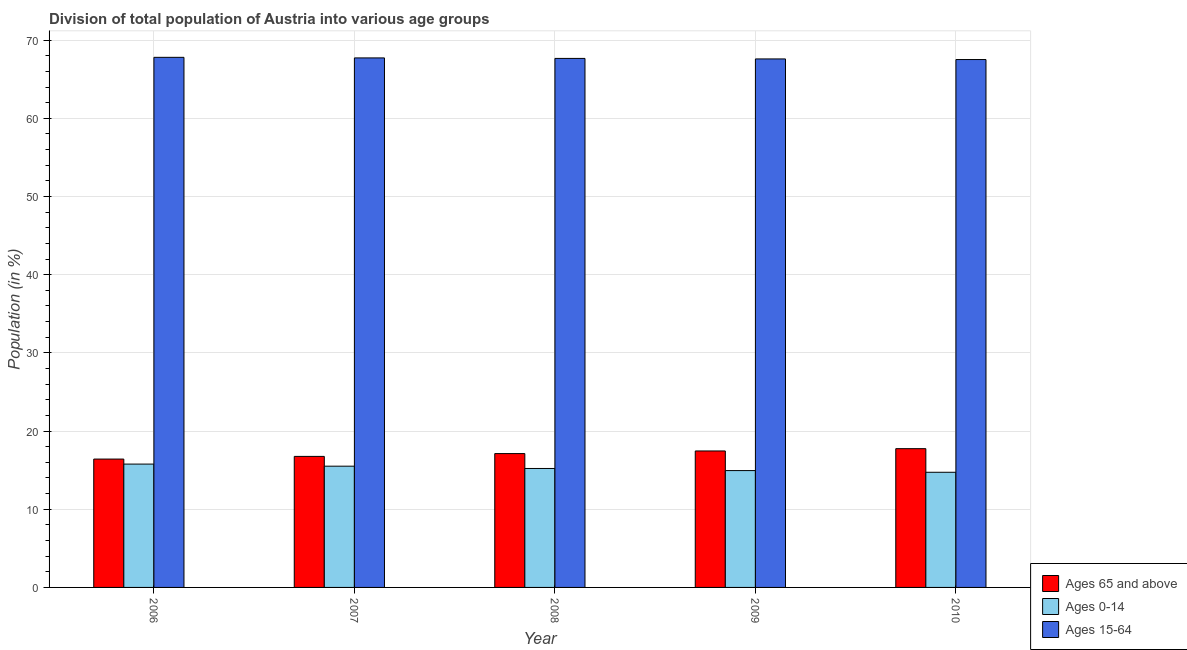How many groups of bars are there?
Your answer should be very brief. 5. Are the number of bars per tick equal to the number of legend labels?
Keep it short and to the point. Yes. How many bars are there on the 1st tick from the left?
Your response must be concise. 3. How many bars are there on the 1st tick from the right?
Your answer should be very brief. 3. What is the label of the 3rd group of bars from the left?
Ensure brevity in your answer.  2008. In how many cases, is the number of bars for a given year not equal to the number of legend labels?
Offer a terse response. 0. What is the percentage of population within the age-group 15-64 in 2006?
Ensure brevity in your answer.  67.81. Across all years, what is the maximum percentage of population within the age-group 15-64?
Your answer should be very brief. 67.81. Across all years, what is the minimum percentage of population within the age-group 0-14?
Ensure brevity in your answer.  14.73. In which year was the percentage of population within the age-group of 65 and above maximum?
Offer a terse response. 2010. What is the total percentage of population within the age-group 15-64 in the graph?
Your answer should be compact. 338.33. What is the difference between the percentage of population within the age-group 15-64 in 2007 and that in 2010?
Provide a succinct answer. 0.21. What is the difference between the percentage of population within the age-group 15-64 in 2006 and the percentage of population within the age-group of 65 and above in 2009?
Ensure brevity in your answer.  0.21. What is the average percentage of population within the age-group 0-14 per year?
Make the answer very short. 15.23. In the year 2008, what is the difference between the percentage of population within the age-group 15-64 and percentage of population within the age-group 0-14?
Provide a succinct answer. 0. What is the ratio of the percentage of population within the age-group of 65 and above in 2006 to that in 2010?
Your response must be concise. 0.93. Is the difference between the percentage of population within the age-group of 65 and above in 2007 and 2008 greater than the difference between the percentage of population within the age-group 15-64 in 2007 and 2008?
Make the answer very short. No. What is the difference between the highest and the second highest percentage of population within the age-group 0-14?
Your response must be concise. 0.27. What is the difference between the highest and the lowest percentage of population within the age-group 0-14?
Offer a terse response. 1.05. In how many years, is the percentage of population within the age-group 15-64 greater than the average percentage of population within the age-group 15-64 taken over all years?
Make the answer very short. 3. Is the sum of the percentage of population within the age-group of 65 and above in 2008 and 2009 greater than the maximum percentage of population within the age-group 15-64 across all years?
Give a very brief answer. Yes. What does the 2nd bar from the left in 2009 represents?
Provide a short and direct response. Ages 0-14. What does the 2nd bar from the right in 2010 represents?
Your answer should be compact. Ages 0-14. How many bars are there?
Offer a very short reply. 15. How many years are there in the graph?
Your answer should be very brief. 5. What is the difference between two consecutive major ticks on the Y-axis?
Offer a very short reply. 10. Where does the legend appear in the graph?
Make the answer very short. Bottom right. How are the legend labels stacked?
Your response must be concise. Vertical. What is the title of the graph?
Your answer should be compact. Division of total population of Austria into various age groups
. What is the label or title of the X-axis?
Give a very brief answer. Year. What is the Population (in %) in Ages 65 and above in 2006?
Your answer should be compact. 16.42. What is the Population (in %) in Ages 0-14 in 2006?
Provide a short and direct response. 15.78. What is the Population (in %) of Ages 15-64 in 2006?
Give a very brief answer. 67.81. What is the Population (in %) of Ages 65 and above in 2007?
Ensure brevity in your answer.  16.76. What is the Population (in %) in Ages 0-14 in 2007?
Give a very brief answer. 15.51. What is the Population (in %) in Ages 15-64 in 2007?
Your answer should be very brief. 67.73. What is the Population (in %) of Ages 65 and above in 2008?
Keep it short and to the point. 17.12. What is the Population (in %) of Ages 0-14 in 2008?
Keep it short and to the point. 15.21. What is the Population (in %) in Ages 15-64 in 2008?
Keep it short and to the point. 67.67. What is the Population (in %) in Ages 65 and above in 2009?
Provide a succinct answer. 17.46. What is the Population (in %) in Ages 0-14 in 2009?
Give a very brief answer. 14.95. What is the Population (in %) in Ages 15-64 in 2009?
Provide a short and direct response. 67.6. What is the Population (in %) of Ages 65 and above in 2010?
Offer a terse response. 17.75. What is the Population (in %) of Ages 0-14 in 2010?
Make the answer very short. 14.73. What is the Population (in %) in Ages 15-64 in 2010?
Ensure brevity in your answer.  67.52. Across all years, what is the maximum Population (in %) of Ages 65 and above?
Provide a short and direct response. 17.75. Across all years, what is the maximum Population (in %) in Ages 0-14?
Give a very brief answer. 15.78. Across all years, what is the maximum Population (in %) of Ages 15-64?
Give a very brief answer. 67.81. Across all years, what is the minimum Population (in %) in Ages 65 and above?
Give a very brief answer. 16.42. Across all years, what is the minimum Population (in %) of Ages 0-14?
Keep it short and to the point. 14.73. Across all years, what is the minimum Population (in %) in Ages 15-64?
Keep it short and to the point. 67.52. What is the total Population (in %) of Ages 65 and above in the graph?
Offer a terse response. 85.5. What is the total Population (in %) of Ages 0-14 in the graph?
Your response must be concise. 76.17. What is the total Population (in %) of Ages 15-64 in the graph?
Ensure brevity in your answer.  338.33. What is the difference between the Population (in %) in Ages 65 and above in 2006 and that in 2007?
Make the answer very short. -0.34. What is the difference between the Population (in %) in Ages 0-14 in 2006 and that in 2007?
Your answer should be compact. 0.27. What is the difference between the Population (in %) of Ages 15-64 in 2006 and that in 2007?
Make the answer very short. 0.07. What is the difference between the Population (in %) of Ages 65 and above in 2006 and that in 2008?
Provide a succinct answer. -0.7. What is the difference between the Population (in %) of Ages 0-14 in 2006 and that in 2008?
Your answer should be compact. 0.56. What is the difference between the Population (in %) in Ages 15-64 in 2006 and that in 2008?
Offer a very short reply. 0.14. What is the difference between the Population (in %) in Ages 65 and above in 2006 and that in 2009?
Offer a very short reply. -1.04. What is the difference between the Population (in %) in Ages 0-14 in 2006 and that in 2009?
Provide a succinct answer. 0.83. What is the difference between the Population (in %) in Ages 15-64 in 2006 and that in 2009?
Keep it short and to the point. 0.21. What is the difference between the Population (in %) of Ages 65 and above in 2006 and that in 2010?
Your answer should be compact. -1.33. What is the difference between the Population (in %) in Ages 0-14 in 2006 and that in 2010?
Your response must be concise. 1.05. What is the difference between the Population (in %) of Ages 15-64 in 2006 and that in 2010?
Your response must be concise. 0.28. What is the difference between the Population (in %) of Ages 65 and above in 2007 and that in 2008?
Make the answer very short. -0.36. What is the difference between the Population (in %) in Ages 0-14 in 2007 and that in 2008?
Provide a short and direct response. 0.29. What is the difference between the Population (in %) of Ages 15-64 in 2007 and that in 2008?
Your answer should be compact. 0.07. What is the difference between the Population (in %) of Ages 65 and above in 2007 and that in 2009?
Provide a short and direct response. -0.7. What is the difference between the Population (in %) in Ages 0-14 in 2007 and that in 2009?
Offer a very short reply. 0.56. What is the difference between the Population (in %) of Ages 15-64 in 2007 and that in 2009?
Ensure brevity in your answer.  0.13. What is the difference between the Population (in %) in Ages 65 and above in 2007 and that in 2010?
Make the answer very short. -0.99. What is the difference between the Population (in %) in Ages 0-14 in 2007 and that in 2010?
Your response must be concise. 0.78. What is the difference between the Population (in %) of Ages 15-64 in 2007 and that in 2010?
Provide a succinct answer. 0.21. What is the difference between the Population (in %) in Ages 65 and above in 2008 and that in 2009?
Your answer should be very brief. -0.34. What is the difference between the Population (in %) of Ages 0-14 in 2008 and that in 2009?
Offer a terse response. 0.27. What is the difference between the Population (in %) of Ages 15-64 in 2008 and that in 2009?
Provide a short and direct response. 0.07. What is the difference between the Population (in %) of Ages 65 and above in 2008 and that in 2010?
Ensure brevity in your answer.  -0.63. What is the difference between the Population (in %) in Ages 0-14 in 2008 and that in 2010?
Provide a succinct answer. 0.49. What is the difference between the Population (in %) of Ages 15-64 in 2008 and that in 2010?
Make the answer very short. 0.14. What is the difference between the Population (in %) of Ages 65 and above in 2009 and that in 2010?
Keep it short and to the point. -0.29. What is the difference between the Population (in %) in Ages 0-14 in 2009 and that in 2010?
Make the answer very short. 0.22. What is the difference between the Population (in %) in Ages 15-64 in 2009 and that in 2010?
Give a very brief answer. 0.08. What is the difference between the Population (in %) in Ages 65 and above in 2006 and the Population (in %) in Ages 0-14 in 2007?
Provide a short and direct response. 0.91. What is the difference between the Population (in %) in Ages 65 and above in 2006 and the Population (in %) in Ages 15-64 in 2007?
Your answer should be compact. -51.31. What is the difference between the Population (in %) in Ages 0-14 in 2006 and the Population (in %) in Ages 15-64 in 2007?
Your response must be concise. -51.95. What is the difference between the Population (in %) of Ages 65 and above in 2006 and the Population (in %) of Ages 0-14 in 2008?
Give a very brief answer. 1.2. What is the difference between the Population (in %) of Ages 65 and above in 2006 and the Population (in %) of Ages 15-64 in 2008?
Your answer should be compact. -51.25. What is the difference between the Population (in %) in Ages 0-14 in 2006 and the Population (in %) in Ages 15-64 in 2008?
Offer a terse response. -51.89. What is the difference between the Population (in %) in Ages 65 and above in 2006 and the Population (in %) in Ages 0-14 in 2009?
Your response must be concise. 1.47. What is the difference between the Population (in %) in Ages 65 and above in 2006 and the Population (in %) in Ages 15-64 in 2009?
Provide a succinct answer. -51.18. What is the difference between the Population (in %) of Ages 0-14 in 2006 and the Population (in %) of Ages 15-64 in 2009?
Keep it short and to the point. -51.82. What is the difference between the Population (in %) of Ages 65 and above in 2006 and the Population (in %) of Ages 0-14 in 2010?
Your response must be concise. 1.69. What is the difference between the Population (in %) in Ages 65 and above in 2006 and the Population (in %) in Ages 15-64 in 2010?
Your response must be concise. -51.11. What is the difference between the Population (in %) in Ages 0-14 in 2006 and the Population (in %) in Ages 15-64 in 2010?
Offer a very short reply. -51.75. What is the difference between the Population (in %) in Ages 65 and above in 2007 and the Population (in %) in Ages 0-14 in 2008?
Your answer should be compact. 1.55. What is the difference between the Population (in %) in Ages 65 and above in 2007 and the Population (in %) in Ages 15-64 in 2008?
Your answer should be very brief. -50.91. What is the difference between the Population (in %) in Ages 0-14 in 2007 and the Population (in %) in Ages 15-64 in 2008?
Your answer should be compact. -52.16. What is the difference between the Population (in %) in Ages 65 and above in 2007 and the Population (in %) in Ages 0-14 in 2009?
Keep it short and to the point. 1.81. What is the difference between the Population (in %) of Ages 65 and above in 2007 and the Population (in %) of Ages 15-64 in 2009?
Your answer should be very brief. -50.84. What is the difference between the Population (in %) in Ages 0-14 in 2007 and the Population (in %) in Ages 15-64 in 2009?
Your response must be concise. -52.09. What is the difference between the Population (in %) in Ages 65 and above in 2007 and the Population (in %) in Ages 0-14 in 2010?
Your response must be concise. 2.03. What is the difference between the Population (in %) of Ages 65 and above in 2007 and the Population (in %) of Ages 15-64 in 2010?
Make the answer very short. -50.76. What is the difference between the Population (in %) of Ages 0-14 in 2007 and the Population (in %) of Ages 15-64 in 2010?
Your response must be concise. -52.01. What is the difference between the Population (in %) in Ages 65 and above in 2008 and the Population (in %) in Ages 0-14 in 2009?
Offer a terse response. 2.17. What is the difference between the Population (in %) in Ages 65 and above in 2008 and the Population (in %) in Ages 15-64 in 2009?
Make the answer very short. -50.48. What is the difference between the Population (in %) of Ages 0-14 in 2008 and the Population (in %) of Ages 15-64 in 2009?
Your answer should be very brief. -52.39. What is the difference between the Population (in %) of Ages 65 and above in 2008 and the Population (in %) of Ages 0-14 in 2010?
Give a very brief answer. 2.39. What is the difference between the Population (in %) in Ages 65 and above in 2008 and the Population (in %) in Ages 15-64 in 2010?
Your response must be concise. -50.4. What is the difference between the Population (in %) in Ages 0-14 in 2008 and the Population (in %) in Ages 15-64 in 2010?
Keep it short and to the point. -52.31. What is the difference between the Population (in %) in Ages 65 and above in 2009 and the Population (in %) in Ages 0-14 in 2010?
Provide a short and direct response. 2.73. What is the difference between the Population (in %) of Ages 65 and above in 2009 and the Population (in %) of Ages 15-64 in 2010?
Your response must be concise. -50.07. What is the difference between the Population (in %) in Ages 0-14 in 2009 and the Population (in %) in Ages 15-64 in 2010?
Your response must be concise. -52.58. What is the average Population (in %) in Ages 65 and above per year?
Ensure brevity in your answer.  17.1. What is the average Population (in %) in Ages 0-14 per year?
Give a very brief answer. 15.23. What is the average Population (in %) of Ages 15-64 per year?
Ensure brevity in your answer.  67.67. In the year 2006, what is the difference between the Population (in %) of Ages 65 and above and Population (in %) of Ages 0-14?
Ensure brevity in your answer.  0.64. In the year 2006, what is the difference between the Population (in %) of Ages 65 and above and Population (in %) of Ages 15-64?
Keep it short and to the point. -51.39. In the year 2006, what is the difference between the Population (in %) of Ages 0-14 and Population (in %) of Ages 15-64?
Make the answer very short. -52.03. In the year 2007, what is the difference between the Population (in %) of Ages 65 and above and Population (in %) of Ages 15-64?
Ensure brevity in your answer.  -50.97. In the year 2007, what is the difference between the Population (in %) in Ages 0-14 and Population (in %) in Ages 15-64?
Your response must be concise. -52.22. In the year 2008, what is the difference between the Population (in %) in Ages 65 and above and Population (in %) in Ages 0-14?
Make the answer very short. 1.91. In the year 2008, what is the difference between the Population (in %) of Ages 65 and above and Population (in %) of Ages 15-64?
Offer a terse response. -50.55. In the year 2008, what is the difference between the Population (in %) of Ages 0-14 and Population (in %) of Ages 15-64?
Keep it short and to the point. -52.45. In the year 2009, what is the difference between the Population (in %) in Ages 65 and above and Population (in %) in Ages 0-14?
Offer a terse response. 2.51. In the year 2009, what is the difference between the Population (in %) in Ages 65 and above and Population (in %) in Ages 15-64?
Keep it short and to the point. -50.14. In the year 2009, what is the difference between the Population (in %) of Ages 0-14 and Population (in %) of Ages 15-64?
Provide a succinct answer. -52.65. In the year 2010, what is the difference between the Population (in %) of Ages 65 and above and Population (in %) of Ages 0-14?
Your response must be concise. 3.02. In the year 2010, what is the difference between the Population (in %) in Ages 65 and above and Population (in %) in Ages 15-64?
Ensure brevity in your answer.  -49.77. In the year 2010, what is the difference between the Population (in %) in Ages 0-14 and Population (in %) in Ages 15-64?
Your answer should be compact. -52.79. What is the ratio of the Population (in %) in Ages 65 and above in 2006 to that in 2007?
Your response must be concise. 0.98. What is the ratio of the Population (in %) of Ages 0-14 in 2006 to that in 2007?
Your answer should be very brief. 1.02. What is the ratio of the Population (in %) of Ages 15-64 in 2006 to that in 2007?
Give a very brief answer. 1. What is the ratio of the Population (in %) in Ages 15-64 in 2006 to that in 2008?
Offer a terse response. 1. What is the ratio of the Population (in %) in Ages 65 and above in 2006 to that in 2009?
Your answer should be compact. 0.94. What is the ratio of the Population (in %) in Ages 0-14 in 2006 to that in 2009?
Make the answer very short. 1.06. What is the ratio of the Population (in %) in Ages 65 and above in 2006 to that in 2010?
Ensure brevity in your answer.  0.93. What is the ratio of the Population (in %) of Ages 0-14 in 2006 to that in 2010?
Offer a terse response. 1.07. What is the ratio of the Population (in %) of Ages 0-14 in 2007 to that in 2008?
Your answer should be compact. 1.02. What is the ratio of the Population (in %) in Ages 65 and above in 2007 to that in 2009?
Your response must be concise. 0.96. What is the ratio of the Population (in %) in Ages 0-14 in 2007 to that in 2009?
Give a very brief answer. 1.04. What is the ratio of the Population (in %) of Ages 15-64 in 2007 to that in 2009?
Offer a very short reply. 1. What is the ratio of the Population (in %) of Ages 65 and above in 2007 to that in 2010?
Provide a short and direct response. 0.94. What is the ratio of the Population (in %) of Ages 0-14 in 2007 to that in 2010?
Make the answer very short. 1.05. What is the ratio of the Population (in %) of Ages 65 and above in 2008 to that in 2009?
Provide a short and direct response. 0.98. What is the ratio of the Population (in %) in Ages 65 and above in 2008 to that in 2010?
Your answer should be very brief. 0.96. What is the ratio of the Population (in %) of Ages 0-14 in 2008 to that in 2010?
Ensure brevity in your answer.  1.03. What is the ratio of the Population (in %) in Ages 65 and above in 2009 to that in 2010?
Make the answer very short. 0.98. What is the ratio of the Population (in %) in Ages 0-14 in 2009 to that in 2010?
Your answer should be compact. 1.01. What is the ratio of the Population (in %) in Ages 15-64 in 2009 to that in 2010?
Provide a short and direct response. 1. What is the difference between the highest and the second highest Population (in %) of Ages 65 and above?
Ensure brevity in your answer.  0.29. What is the difference between the highest and the second highest Population (in %) in Ages 0-14?
Ensure brevity in your answer.  0.27. What is the difference between the highest and the second highest Population (in %) in Ages 15-64?
Ensure brevity in your answer.  0.07. What is the difference between the highest and the lowest Population (in %) in Ages 65 and above?
Give a very brief answer. 1.33. What is the difference between the highest and the lowest Population (in %) of Ages 0-14?
Your answer should be compact. 1.05. What is the difference between the highest and the lowest Population (in %) in Ages 15-64?
Offer a very short reply. 0.28. 